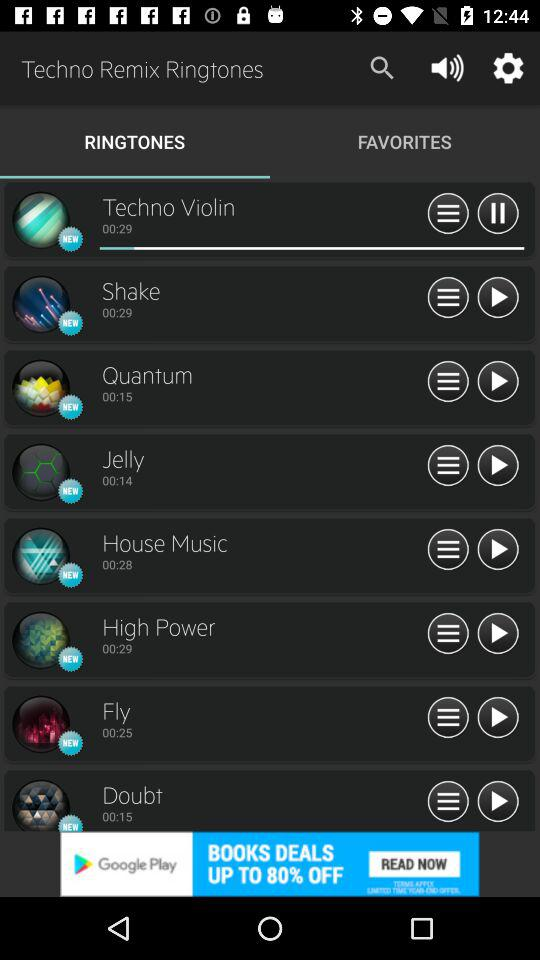What's the current playing ringtone? The current playing ringtone is "Techno Violin". 